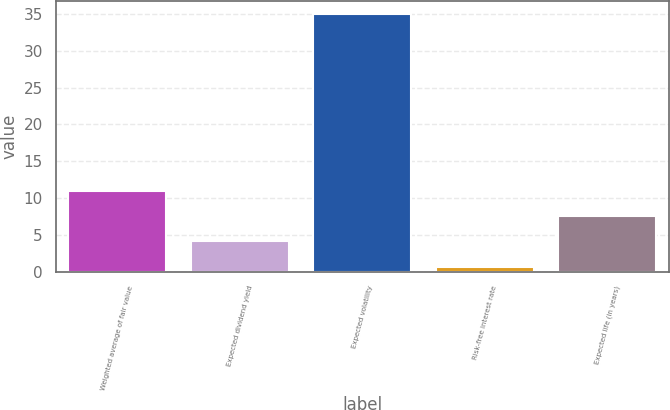Convert chart to OTSL. <chart><loc_0><loc_0><loc_500><loc_500><bar_chart><fcel>Weighted average of fair value<fcel>Expected dividend yield<fcel>Expected volatility<fcel>Risk-free interest rate<fcel>Expected life (in years)<nl><fcel>10.96<fcel>4.1<fcel>35<fcel>0.67<fcel>7.53<nl></chart> 